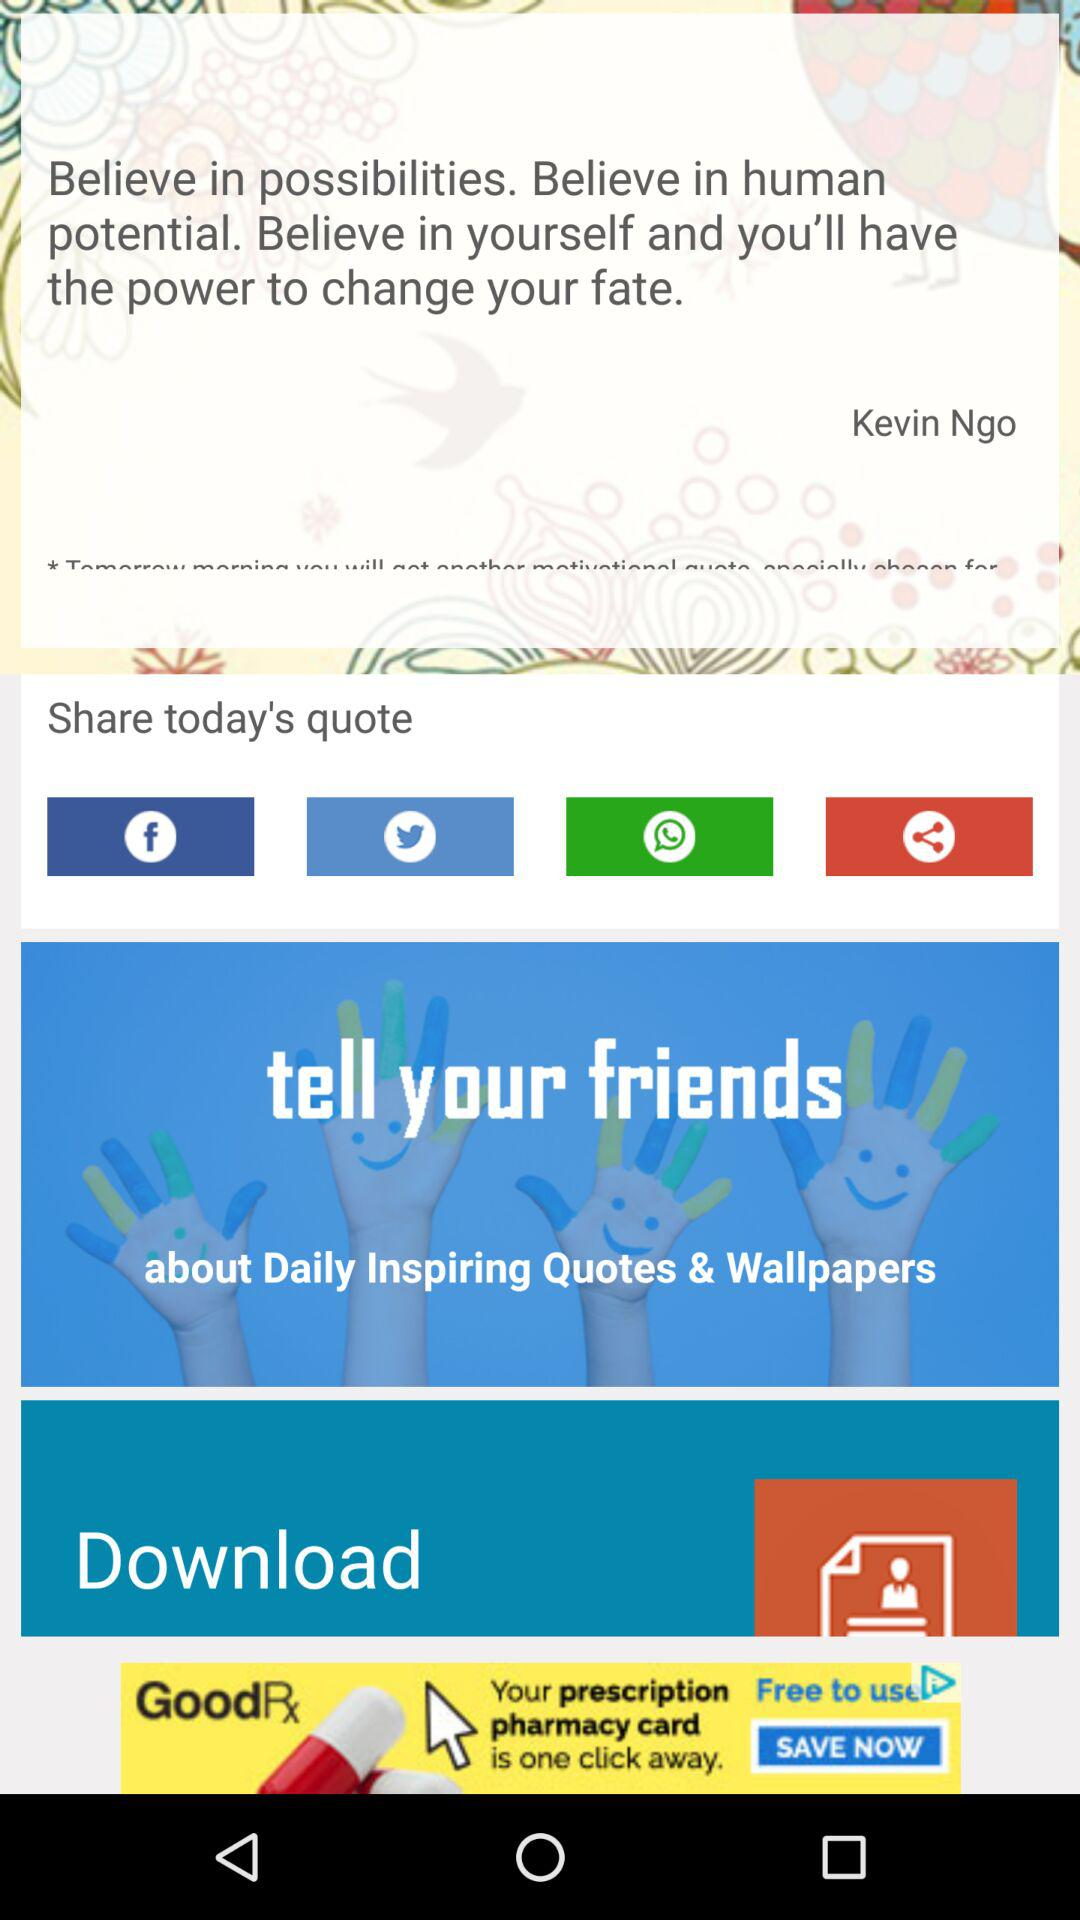By whom was the quote written? The quote was written by Kevin Ngo. 